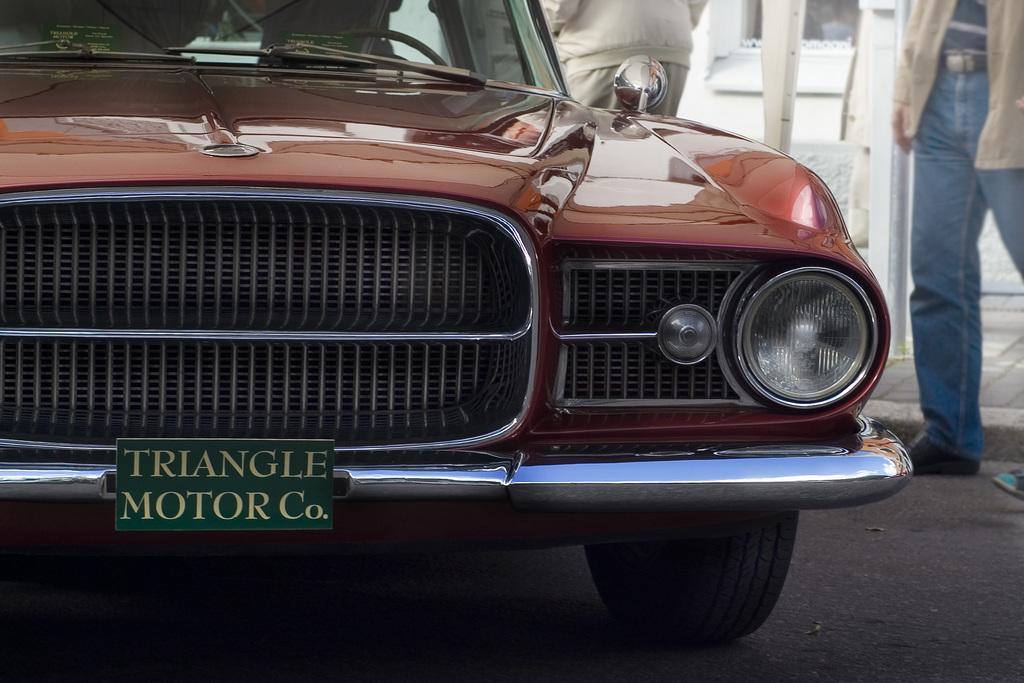Describe this image in one or two sentences. In this image there are persons towards the top of the image, there is a car towards the left of the image, there is a board on the car, there is text on the board, there is road towards the bottom of the image, there is an object towards the top of the image there are looks like a pole, there is a window towards the top of the image, at the background of the image there is a wall. 